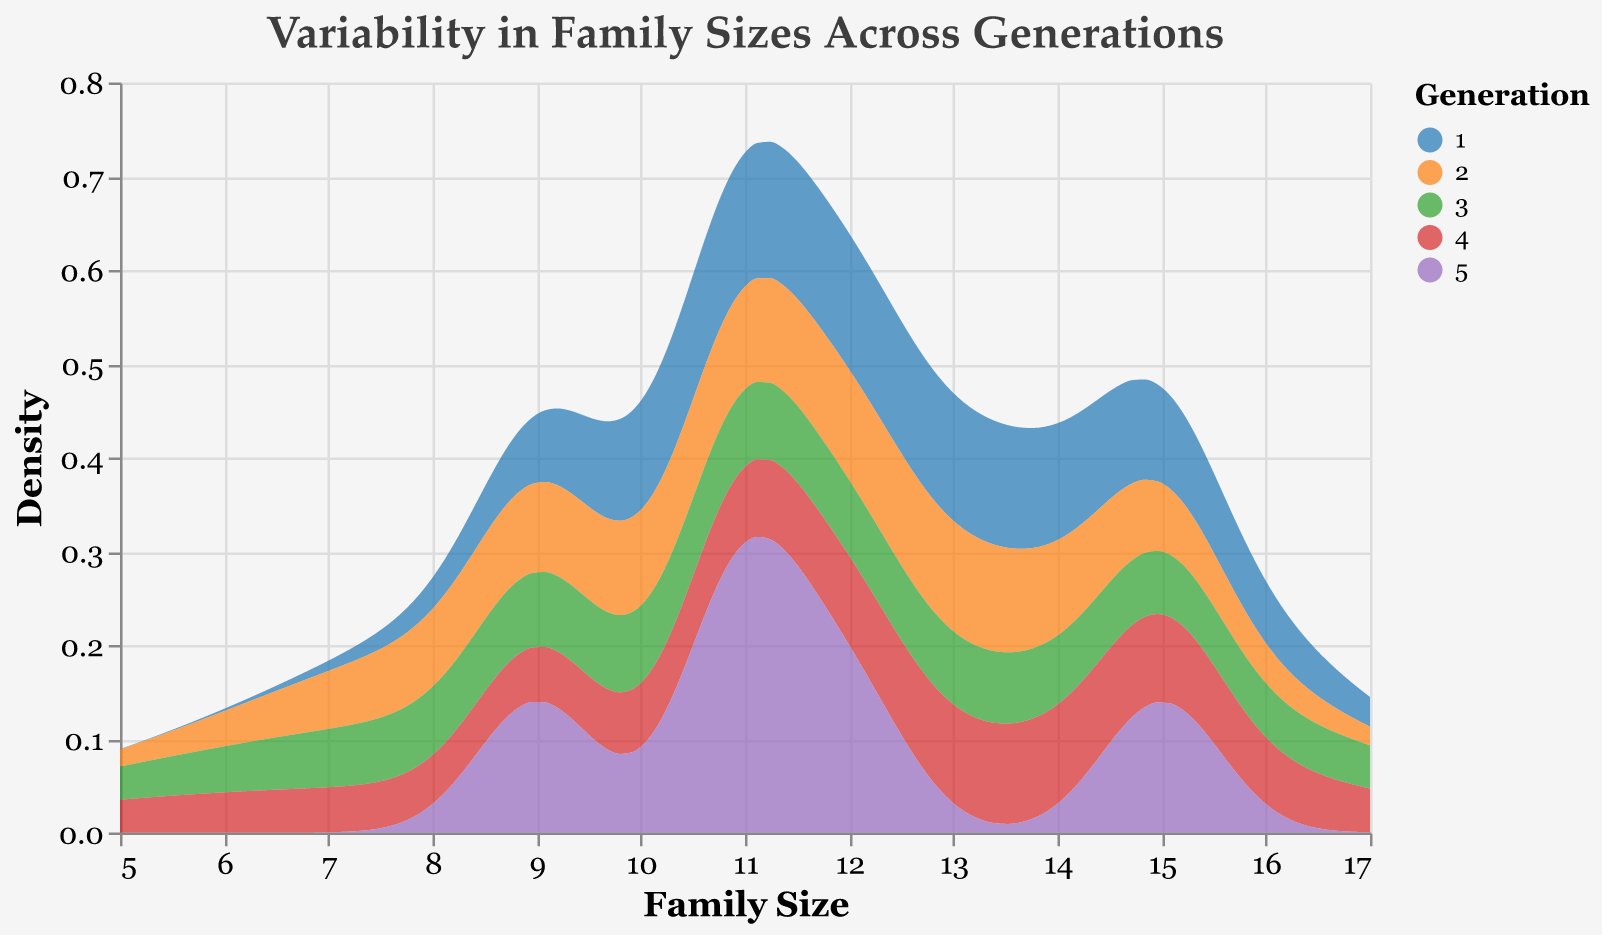What is the title of the figure? The title is usually displayed at the top of the figure and provides a summary of what the figure represents. It is visible without needing to analyze the details within the figure.
Answer: "Variability in Family Sizes Across Generations" Which axis represents the family size? By inspecting the axis labels on the figure, the axis that has the label "Family Size" represents family size.
Answer: x-axis How many generations are represented in the figure? The number of unique colors in the legend corresponds to the number of generations since each color represents a different generation.
Answer: 5 Which generation shows the highest density for a family size around 15? In the density plot, observe where the peaks are along the x-axis value of 15. The color indicating the generation at that peak will reveal the answer.
Answer: Generation 3 Does any generation have a density peak near a family size of 10? Look at the x-axis value of 10 and check if any of the density curves reach a maximum at that point. The color of the curve will indicate the generation.
Answer: No What trend can be observed in the family size of the Bearclaw family over the generations? Analyze the positions of the peaks or curves associated with the Bearclaw family across generations to determine if their family size is increasing, decreasing, or fluctuating.
Answer: Decreasing Compare the density peak heights of Generation 1 and Generation 5. Which is higher? Carefully compare the highest points of the curves for Generations 1 and 5. The taller peak represents the higher density.
Answer: Generation 1 What is the range of family sizes covered in this figure? Find the minimum and maximum values on the x-axis to determine the full range of family sizes included in the plot.
Answer: 5 to 17 Which generation shows the least variability in family sizes? The generation with the narrowest curve or the smallest spread in its density plot indicates the least variability.
Answer: Generation 4 Is there any generation where the density for family size 7 is notably higher than others? Examine the height of the density curves around the family size of 7 and compare them across generations. The generation with the more pronounced peak represents higher density.
Answer: Generation 5 